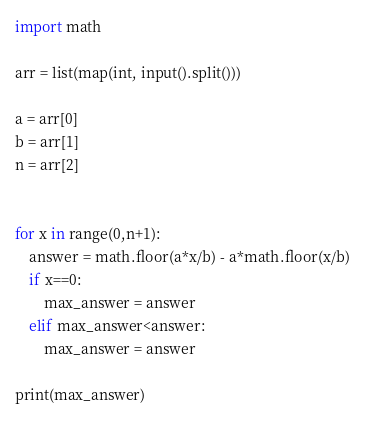Convert code to text. <code><loc_0><loc_0><loc_500><loc_500><_Python_>import math

arr = list(map(int, input().split()))

a = arr[0]
b = arr[1]
n = arr[2]


for x in range(0,n+1):
    answer = math.floor(a*x/b) - a*math.floor(x/b)
    if x==0:
        max_answer = answer
    elif max_answer<answer:
        max_answer = answer

print(max_answer)
</code> 